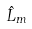Convert formula to latex. <formula><loc_0><loc_0><loc_500><loc_500>\hat { L } _ { m }</formula> 